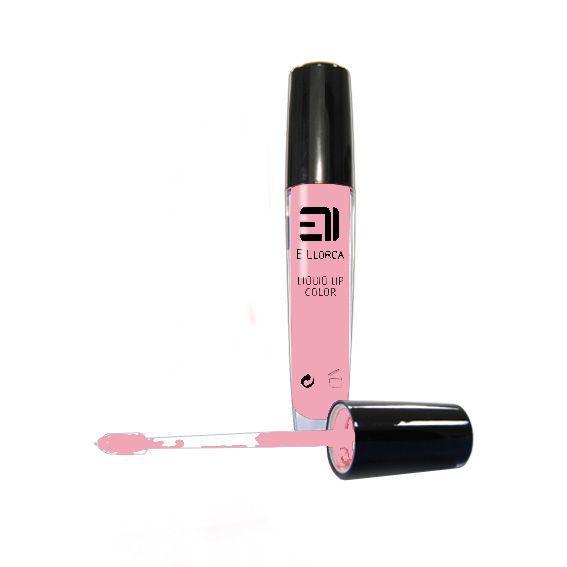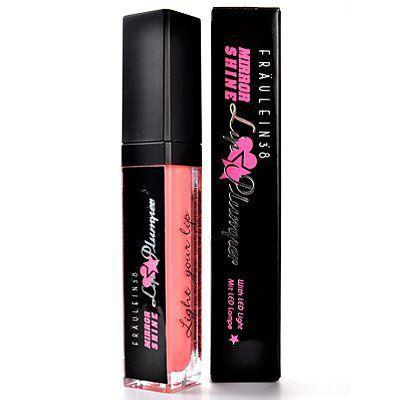The first image is the image on the left, the second image is the image on the right. Assess this claim about the two images: "One of the images shows a foam-tipped lip applicator.". Correct or not? Answer yes or no. Yes. The first image is the image on the left, the second image is the image on the right. Given the left and right images, does the statement "An image includes one exposed lipstick wand and no tube lipsticks." hold true? Answer yes or no. Yes. 